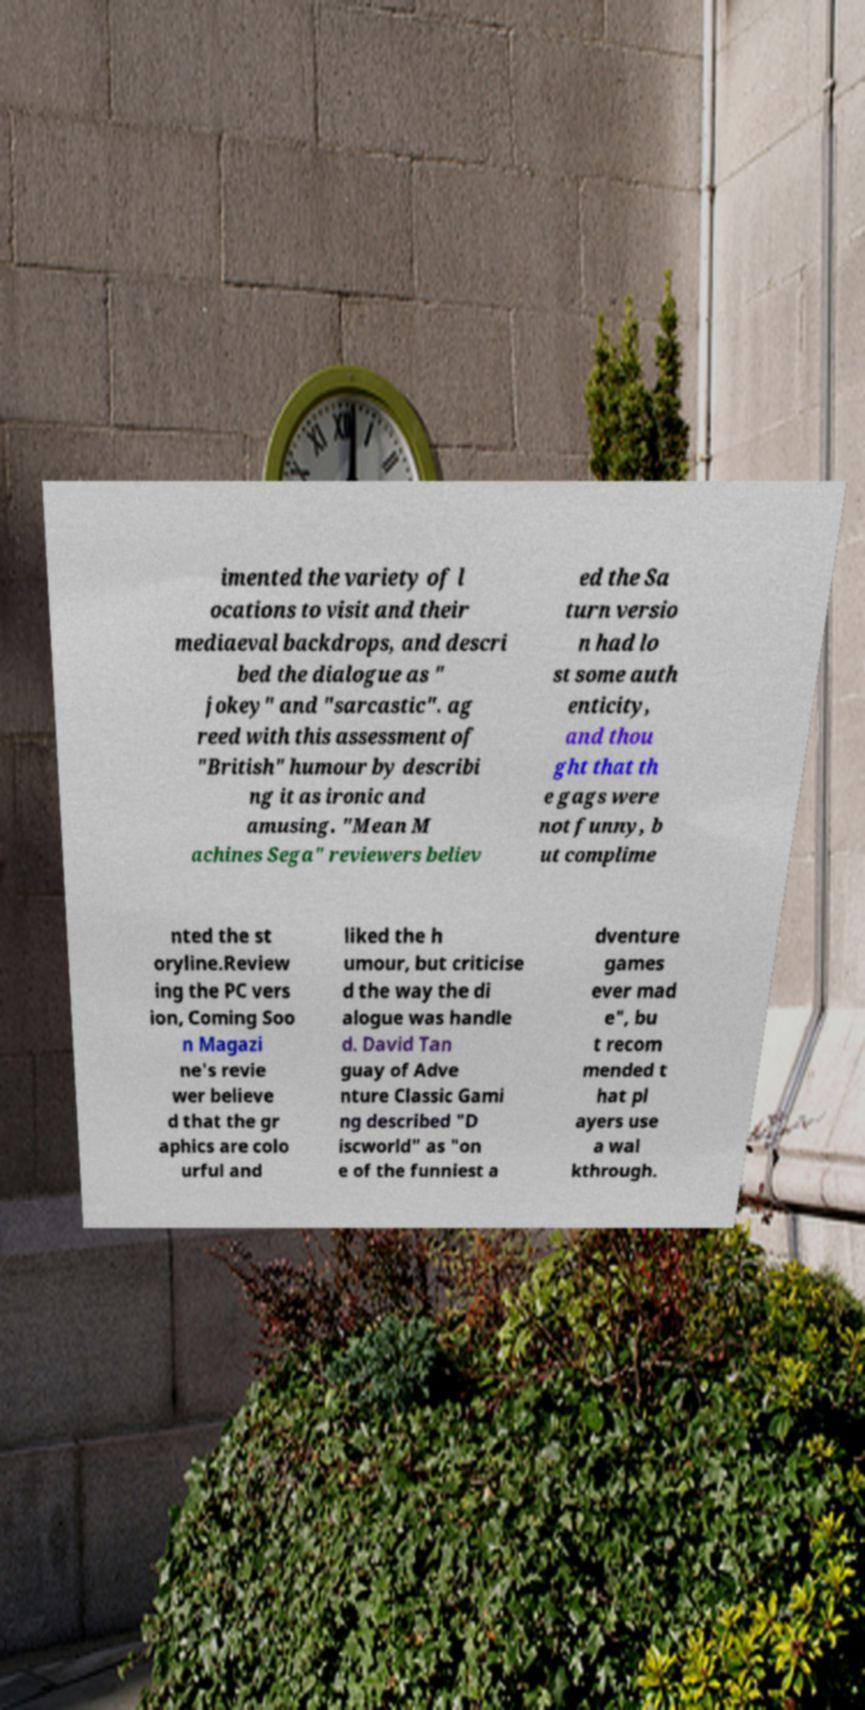Could you assist in decoding the text presented in this image and type it out clearly? imented the variety of l ocations to visit and their mediaeval backdrops, and descri bed the dialogue as " jokey" and "sarcastic". ag reed with this assessment of "British" humour by describi ng it as ironic and amusing. "Mean M achines Sega" reviewers believ ed the Sa turn versio n had lo st some auth enticity, and thou ght that th e gags were not funny, b ut complime nted the st oryline.Review ing the PC vers ion, Coming Soo n Magazi ne's revie wer believe d that the gr aphics are colo urful and liked the h umour, but criticise d the way the di alogue was handle d. David Tan guay of Adve nture Classic Gami ng described "D iscworld" as "on e of the funniest a dventure games ever mad e", bu t recom mended t hat pl ayers use a wal kthrough. 